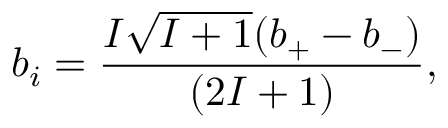<formula> <loc_0><loc_0><loc_500><loc_500>b _ { i } = \frac { I \sqrt { I + 1 } ( b _ { + } - b _ { - } ) } { ( 2 I + 1 ) } ,</formula> 